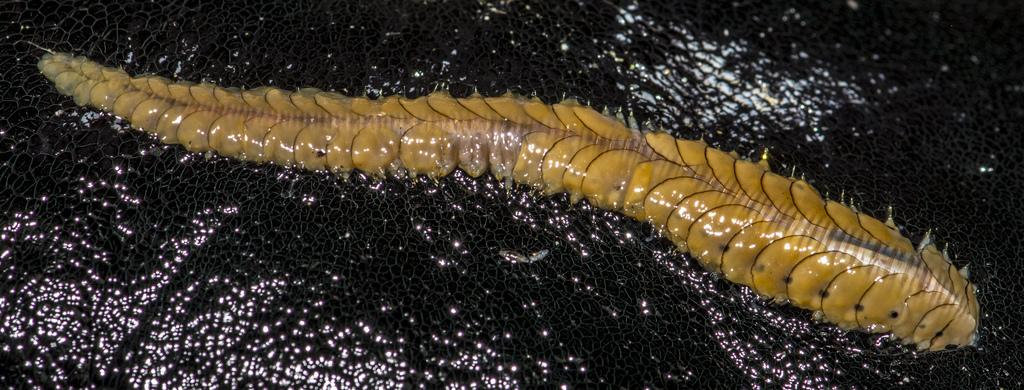What type of insect is in the image? There is a yellow insect in the image. What color is the surface on which the insect is located? The insect is on a black surface. What type of juice is being served at the airport in the image? There is no airport or juice present in the image; it only features a yellow insect on a black surface. 